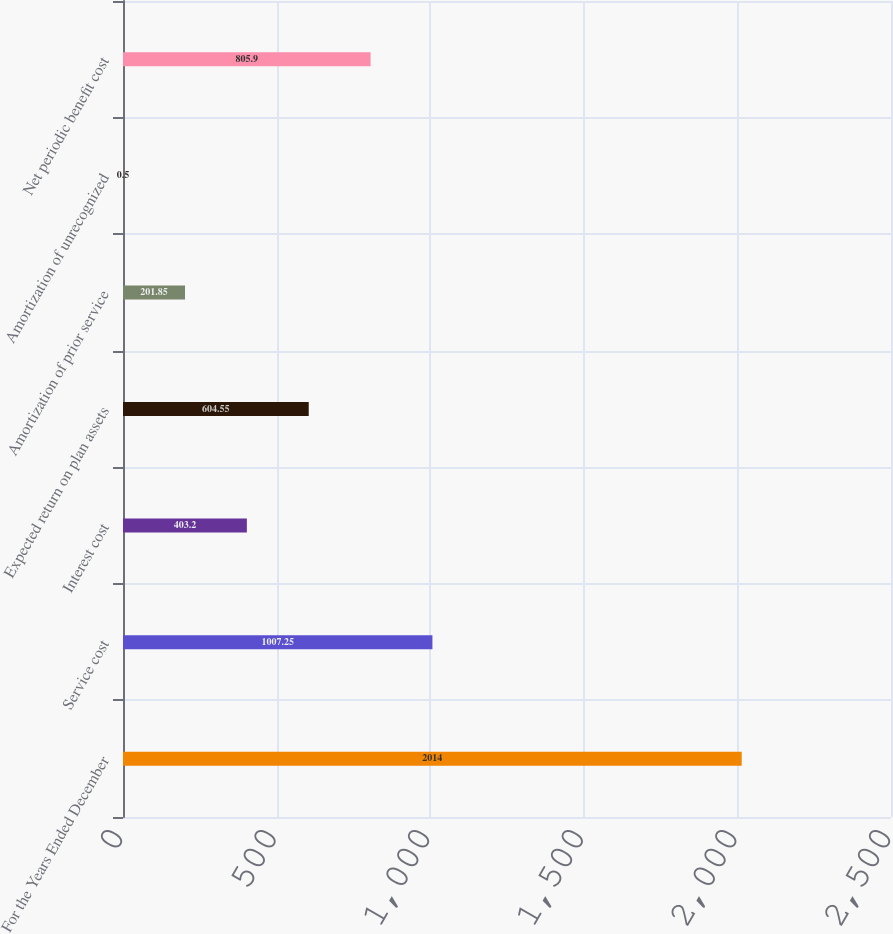Convert chart to OTSL. <chart><loc_0><loc_0><loc_500><loc_500><bar_chart><fcel>For the Years Ended December<fcel>Service cost<fcel>Interest cost<fcel>Expected return on plan assets<fcel>Amortization of prior service<fcel>Amortization of unrecognized<fcel>Net periodic benefit cost<nl><fcel>2014<fcel>1007.25<fcel>403.2<fcel>604.55<fcel>201.85<fcel>0.5<fcel>805.9<nl></chart> 